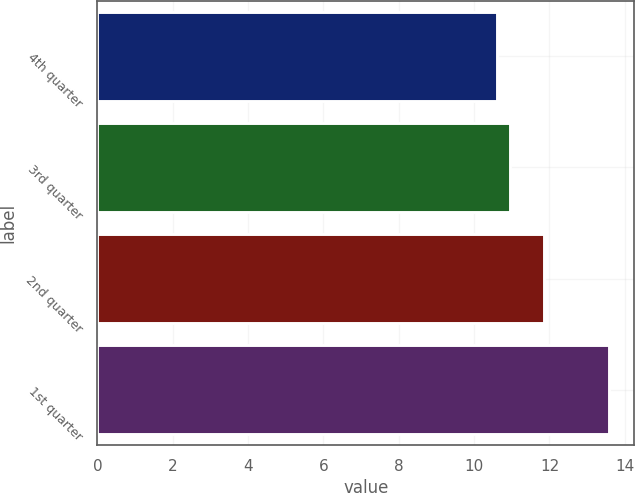<chart> <loc_0><loc_0><loc_500><loc_500><bar_chart><fcel>4th quarter<fcel>3rd quarter<fcel>2nd quarter<fcel>1st quarter<nl><fcel>10.6<fcel>10.95<fcel>11.86<fcel>13.57<nl></chart> 